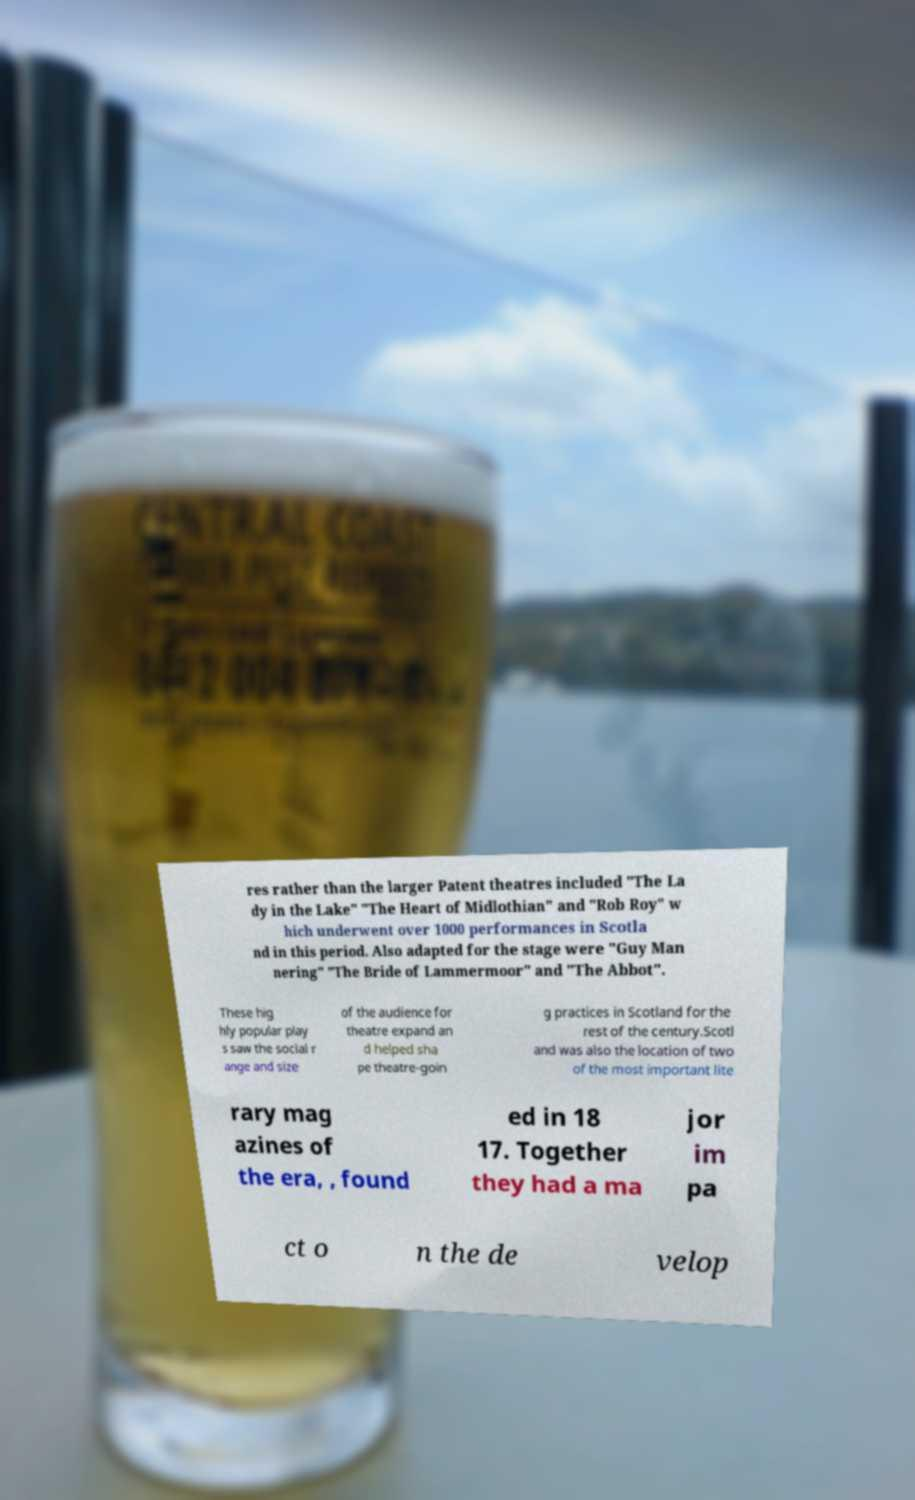Please read and relay the text visible in this image. What does it say? res rather than the larger Patent theatres included "The La dy in the Lake" "The Heart of Midlothian" and "Rob Roy" w hich underwent over 1000 performances in Scotla nd in this period. Also adapted for the stage were "Guy Man nering" "The Bride of Lammermoor" and "The Abbot". These hig hly popular play s saw the social r ange and size of the audience for theatre expand an d helped sha pe theatre-goin g practices in Scotland for the rest of the century.Scotl and was also the location of two of the most important lite rary mag azines of the era, , found ed in 18 17. Together they had a ma jor im pa ct o n the de velop 